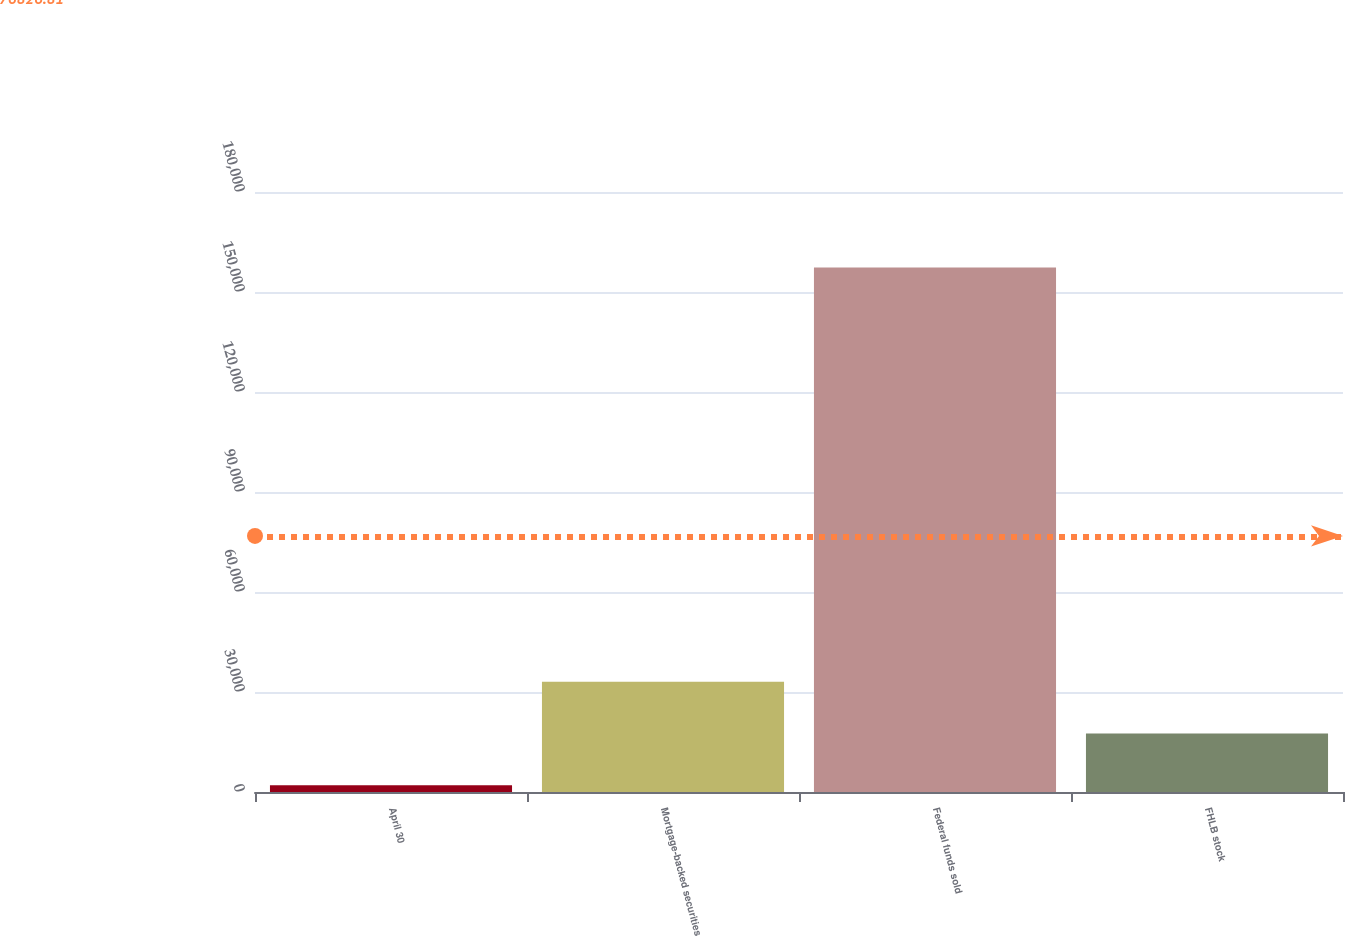Convert chart to OTSL. <chart><loc_0><loc_0><loc_500><loc_500><bar_chart><fcel>April 30<fcel>Mortgage-backed securities<fcel>Federal funds sold<fcel>FHLB stock<nl><fcel>2009<fcel>33072.4<fcel>157326<fcel>17540.7<nl></chart> 